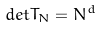Convert formula to latex. <formula><loc_0><loc_0><loc_500><loc_500>d e t T _ { N } = N ^ { d }</formula> 